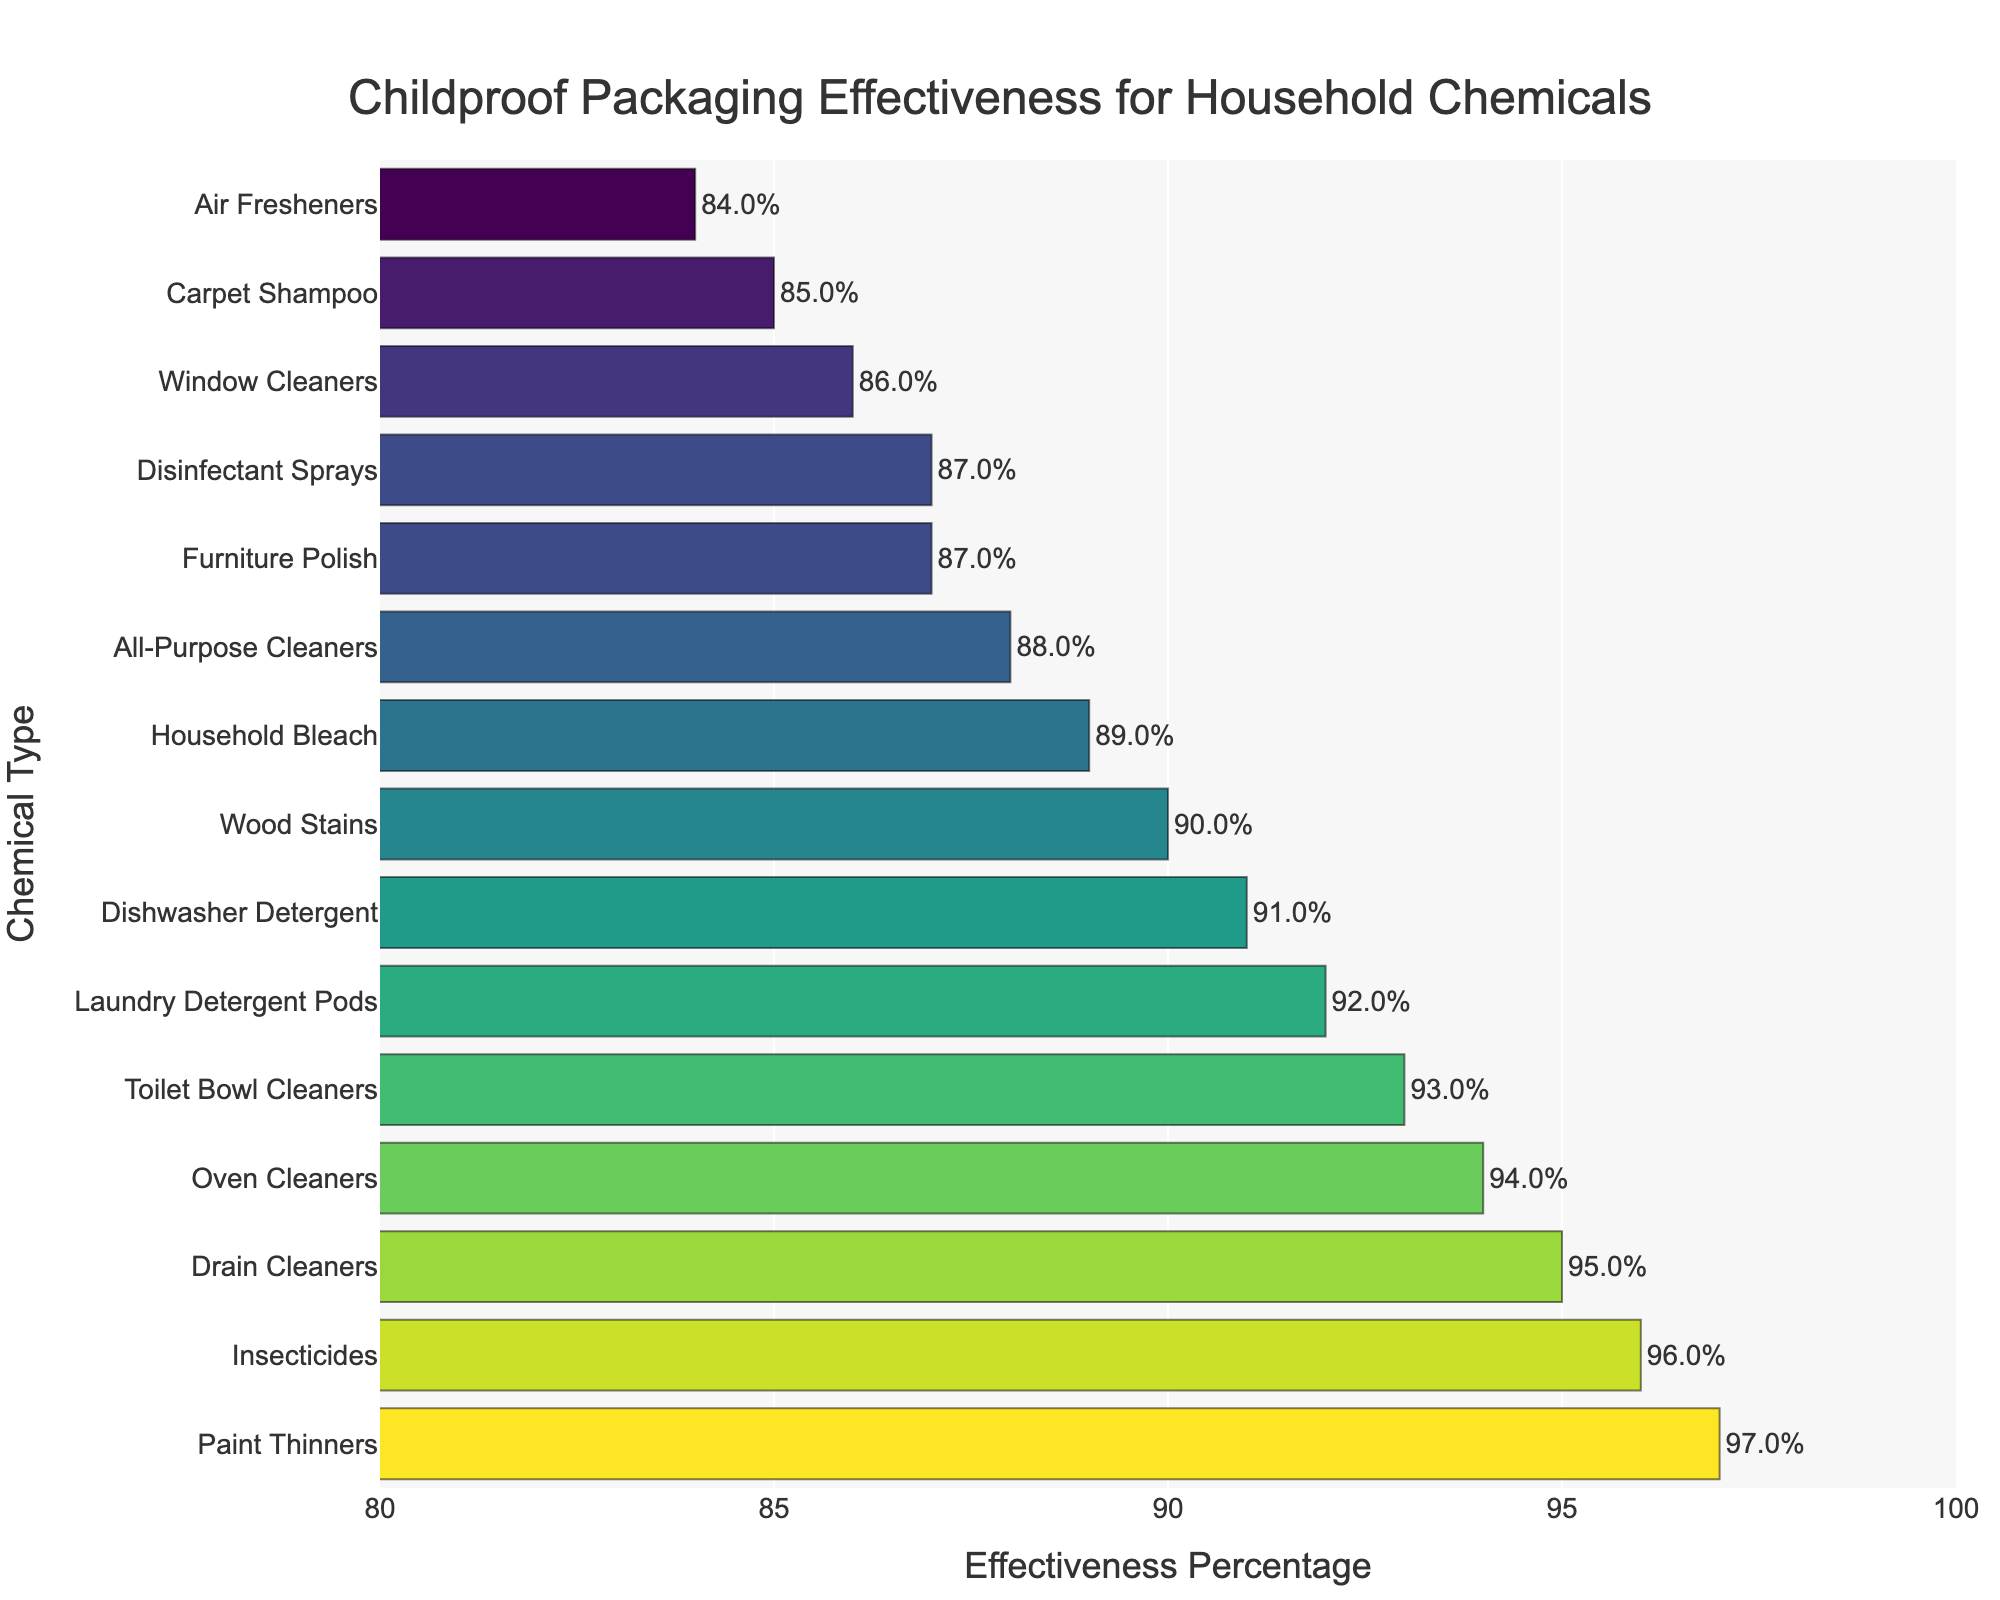Which chemical has the highest percentage of childproof packaging effectiveness? Look at the top bar in the chart. The highest effectiveness percentage is 97% for Paint Thinners.
Answer: Paint Thinners Which two chemicals have the lowest percentages of childproof packaging effectiveness? Look at the bottom bars in the chart. The two chemicals with the lowest percentages are Carpet Shampoo (85%) and Air Fresheners (84%).
Answer: Carpet Shampoo and Air Fresheners What is the effectiveness percentage for Oven Cleaners? Locate Oven Cleaners on the y-axis, and then check the corresponding bar on the x-axis. The effectiveness percentage for Oven Cleaners is 94%.
Answer: 94% Which chemical has a higher effectiveness percentage: Household Bleach or Laundry Detergent Pods? Compare the effectiveness percentages of Household Bleach (89%) and Laundry Detergent Pods (92%). Laundry Detergent Pods has a higher percentage.
Answer: Laundry Detergent Pods What is the average effectiveness percentage for the top three chemicals? The top three chemicals are Paint Thinners (97%), Insecticides (96%), and Drain Cleaners (95%). The average is calculated as (97 + 96 + 95) / 3 = 96%.
Answer: 96% What's the difference in effectiveness percentage between Window Cleaners and Dishwasher Detergent? Find the effectiveness percentages for Window Cleaners (86%) and Dishwasher Detergent (91%) and calculate the difference: 91 - 86 = 5%.
Answer: 5% Which chemical type has a 90% effectiveness in childproof packaging? Look for the bar or label that shows 90% effectiveness. Wood Stains has an effectiveness of 90%.
Answer: Wood Stains How many chemicals have an effectiveness percentage of 94% or higher? Count the bars that show an effectiveness percentage of 94% or higher. There are five such chemicals: Paint Thinners (97%), Insecticides (96%), Drain Cleaners (95%), Oven Cleaners (94%), and Toilet Bowl Cleaners (93%).
Answer: 5 Among All-Purpose Cleaners, Household Bleach, and Furniture Polish, which has the lowest effectiveness percentage? Compare the effectiveness percentages of All-Purpose Cleaners (88%), Household Bleach (89%), and Furniture Polish (87%). Furniture Polish has the lowest percentage.
Answer: Furniture Polish What's the combined effectiveness percentage of Air Fresheners and Carpet Shampoo? Add the effectiveness percentages of Air Fresheners (84%) and Carpet Shampoo (85%): 84 + 85 = 169%.
Answer: 169% 